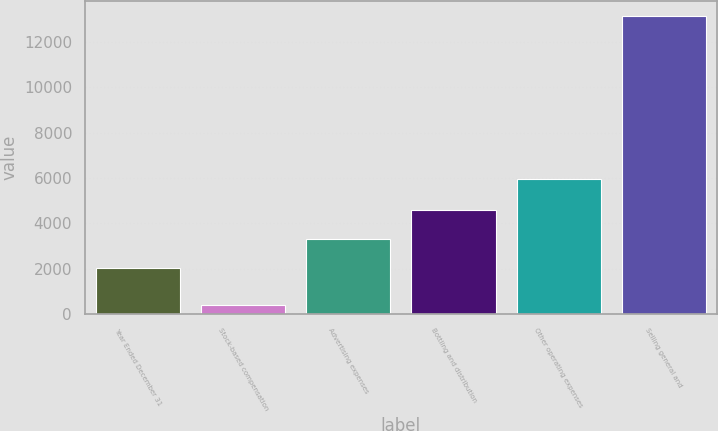Convert chart. <chart><loc_0><loc_0><loc_500><loc_500><bar_chart><fcel>Year Ended December 31<fcel>Stock-based compensation<fcel>Advertising expenses<fcel>Bottling and distribution<fcel>Other operating expenses<fcel>Selling general and<nl><fcel>2010<fcel>380<fcel>3287.8<fcel>4565.6<fcel>5959<fcel>13158<nl></chart> 